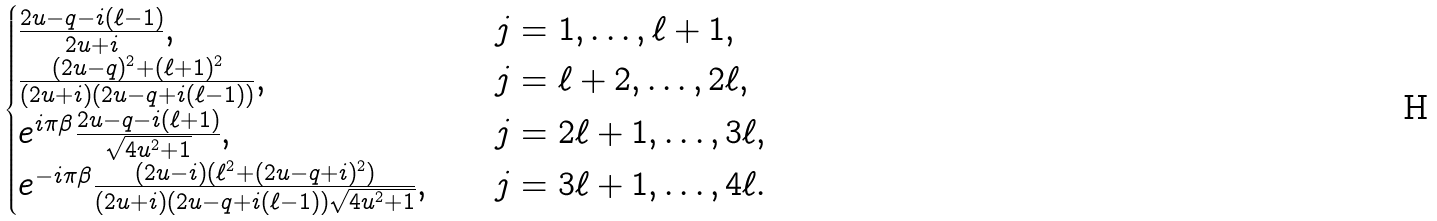<formula> <loc_0><loc_0><loc_500><loc_500>\begin{cases} \frac { 2 u - q - i ( \ell - 1 ) } { 2 u + i } , & \quad j = 1 , \dots , \ell + 1 , \\ \frac { ( 2 u - q ) ^ { 2 } + ( \ell + 1 ) ^ { 2 } } { ( 2 u + i ) ( 2 u - q + i ( \ell - 1 ) ) } , & \quad j = \ell + 2 , \dots , 2 \ell , \\ e ^ { i \pi \beta } \frac { 2 u - q - i ( \ell + 1 ) } { \sqrt { 4 u ^ { 2 } + 1 } } , & \quad j = 2 \ell + 1 , \dots , 3 \ell , \\ e ^ { - i \pi \beta } \frac { ( 2 u - i ) ( \ell ^ { 2 } + ( 2 u - q + i ) ^ { 2 } ) } { ( 2 u + i ) ( 2 u - q + i ( \ell - 1 ) ) \sqrt { 4 u ^ { 2 } + 1 } } , & \quad j = 3 \ell + 1 , \dots , 4 \ell . \end{cases}</formula> 